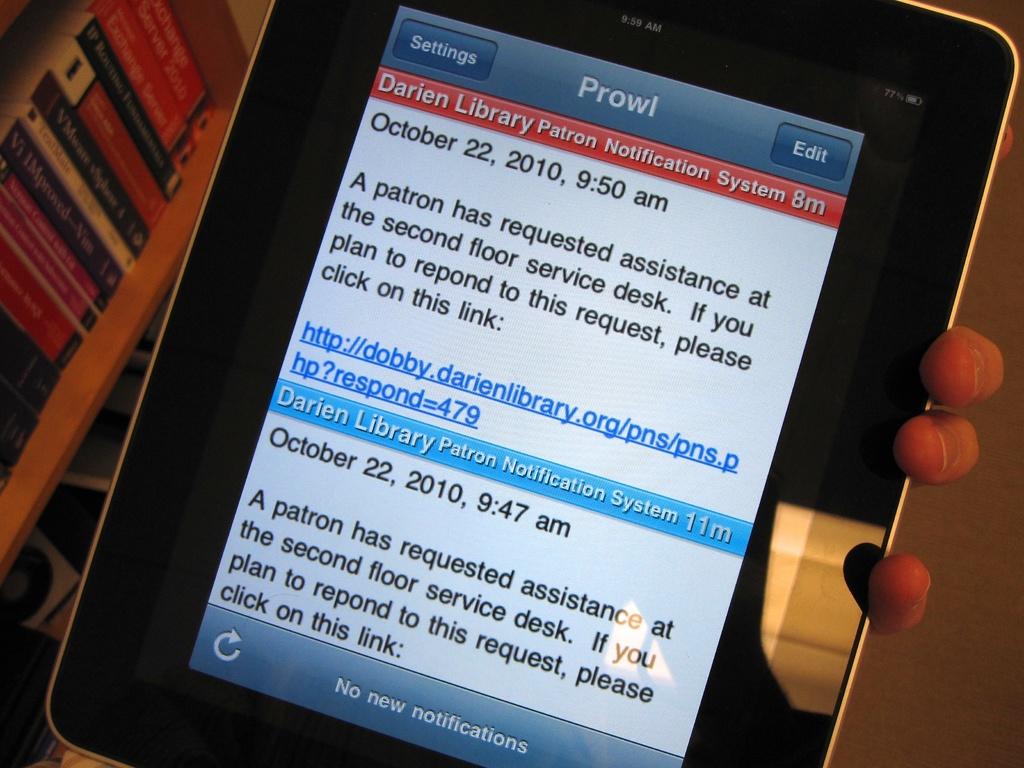What date were the messages sent?
Your response must be concise. October 22, 2010. Who has requested assistance?
Your answer should be compact. A patron. 